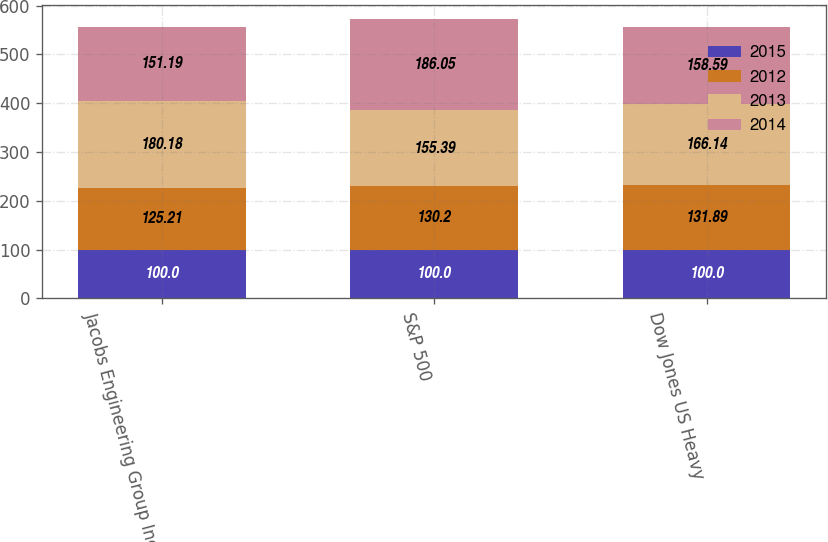Convert chart. <chart><loc_0><loc_0><loc_500><loc_500><stacked_bar_chart><ecel><fcel>Jacobs Engineering Group Inc<fcel>S&P 500<fcel>Dow Jones US Heavy<nl><fcel>2015<fcel>100<fcel>100<fcel>100<nl><fcel>2012<fcel>125.21<fcel>130.2<fcel>131.89<nl><fcel>2013<fcel>180.18<fcel>155.39<fcel>166.14<nl><fcel>2014<fcel>151.19<fcel>186.05<fcel>158.59<nl></chart> 